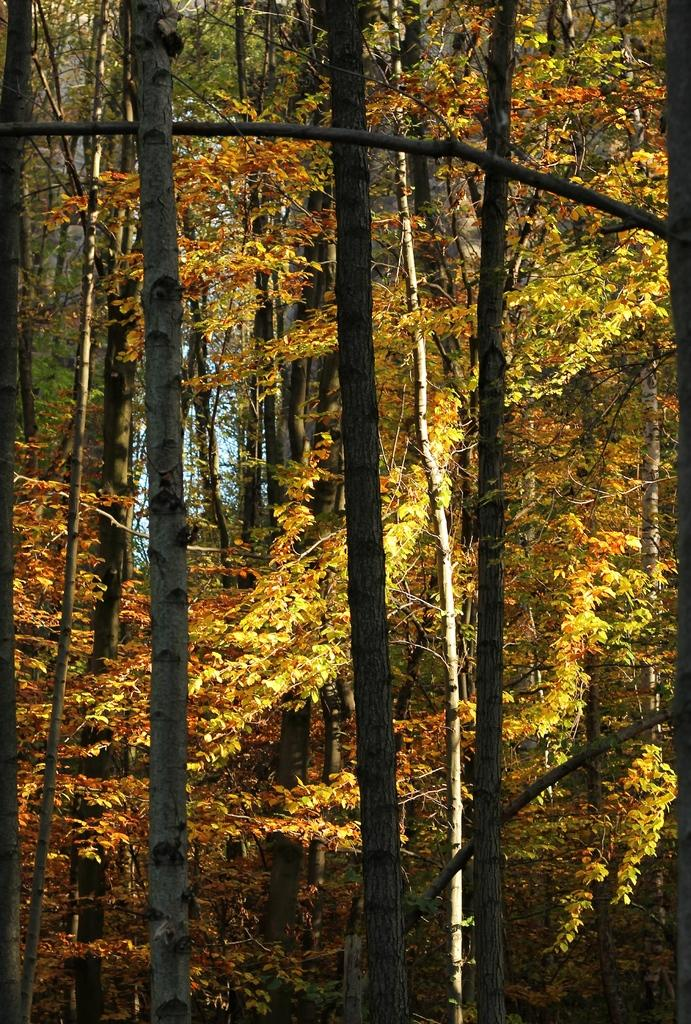What type of vegetation can be seen in the image? There are trees in the image. What type of waste is visible in the image? There is no waste visible in the image; it only features trees. What type of celery is growing among the trees in the image? There is no celery present in the image; it only features trees. 